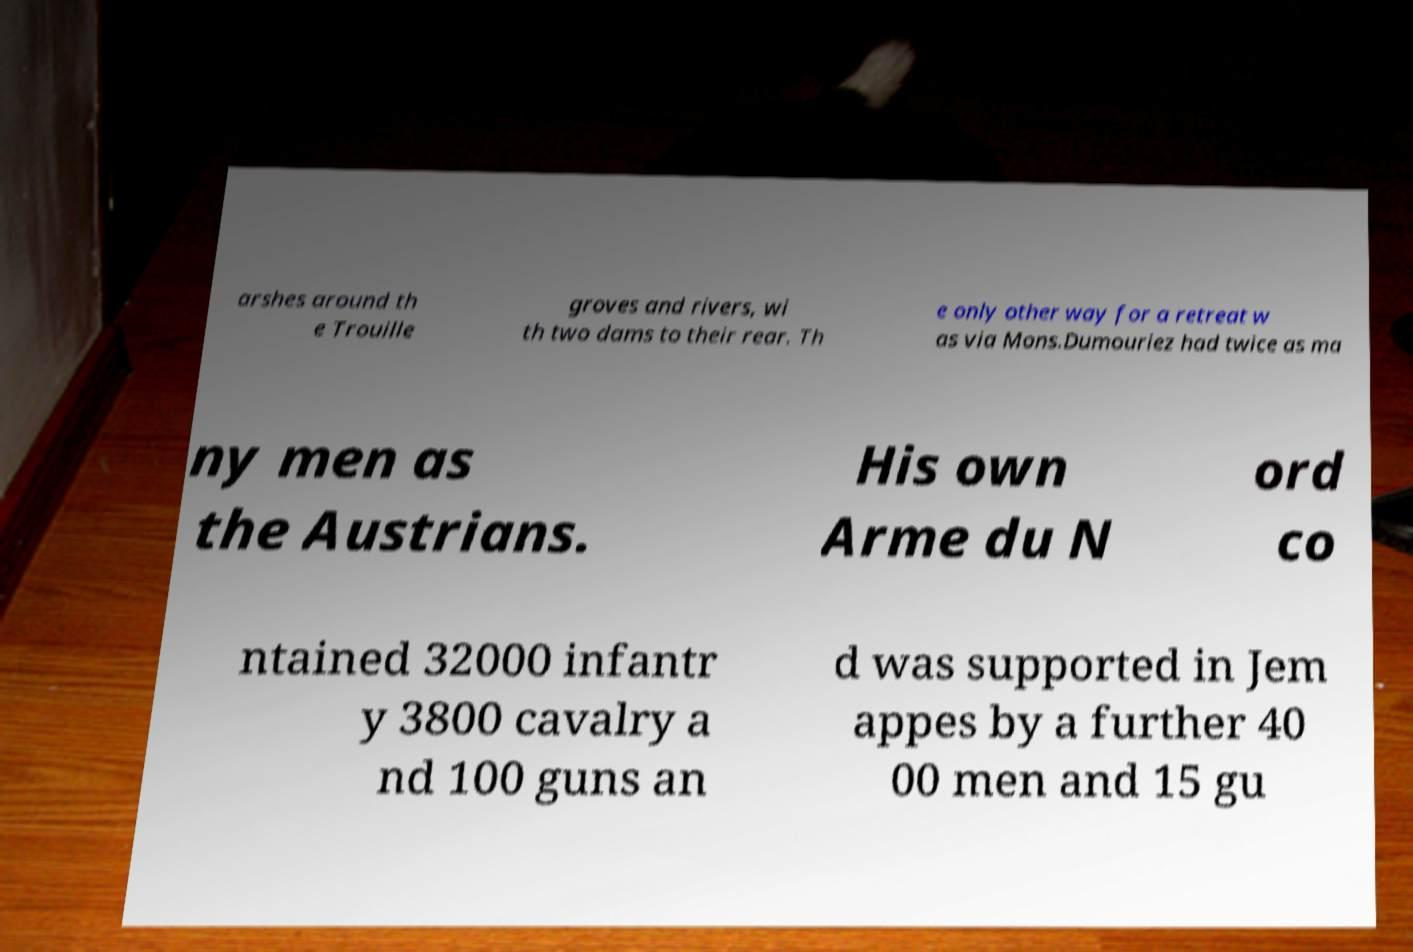Please identify and transcribe the text found in this image. arshes around th e Trouille groves and rivers, wi th two dams to their rear. Th e only other way for a retreat w as via Mons.Dumouriez had twice as ma ny men as the Austrians. His own Arme du N ord co ntained 32000 infantr y 3800 cavalry a nd 100 guns an d was supported in Jem appes by a further 40 00 men and 15 gu 